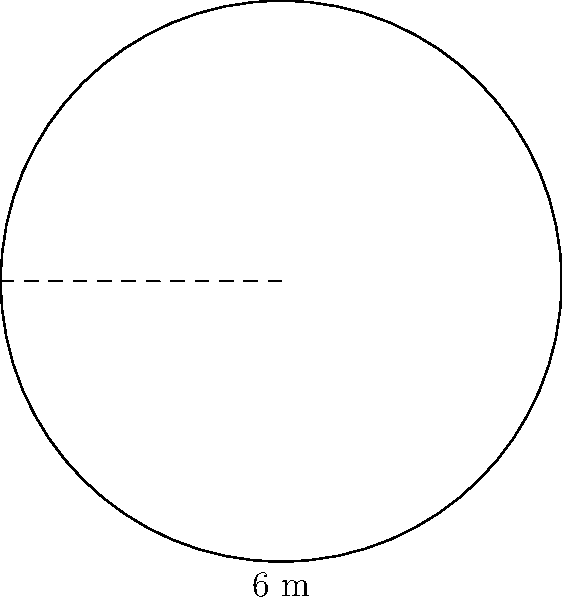You're planning to create a circular outdoor seating area for customers outside your grocery store. If the diameter of the seating area is 6 meters, what is the total area available for seating? To solve this problem, we'll follow these steps:

1. Identify the given information:
   - The seating area is circular
   - The diameter is 6 meters

2. Calculate the radius:
   - Radius = Diameter ÷ 2
   - Radius = 6 m ÷ 2 = 3 m

3. Recall the formula for the area of a circle:
   $A = \pi r^2$, where $A$ is the area and $r$ is the radius

4. Substitute the radius value into the formula:
   $A = \pi (3\text{ m})^2$

5. Calculate the area:
   $A = \pi \cdot 9\text{ m}^2 = 28.27\text{ m}^2$ (rounded to two decimal places)

Therefore, the total area available for seating is approximately 28.27 square meters.
Answer: $28.27\text{ m}^2$ 